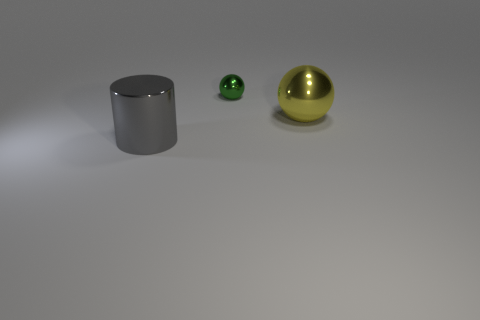There is a large ball; is it the same color as the ball that is on the left side of the big yellow shiny ball?
Offer a terse response. No. What color is the metallic object that is both left of the large yellow metallic thing and in front of the tiny green object?
Provide a succinct answer. Gray. The large thing that is right of the thing that is in front of the big metallic thing that is behind the large gray cylinder is made of what material?
Your answer should be very brief. Metal. What is the size of the other object that is the same shape as the big yellow shiny thing?
Provide a short and direct response. Small. What number of other things are there of the same material as the gray object
Keep it short and to the point. 2. Is the number of metal spheres that are left of the large shiny cylinder the same as the number of big red matte cylinders?
Offer a terse response. Yes. Is the size of the shiny cylinder in front of the green sphere the same as the yellow metallic thing?
Provide a short and direct response. Yes. There is a big gray metallic cylinder; what number of metallic things are to the right of it?
Give a very brief answer. 2. There is a object that is both on the left side of the large yellow metallic thing and in front of the green shiny sphere; what material is it made of?
Make the answer very short. Metal. What number of big objects are metal balls or green metallic objects?
Provide a succinct answer. 1. 